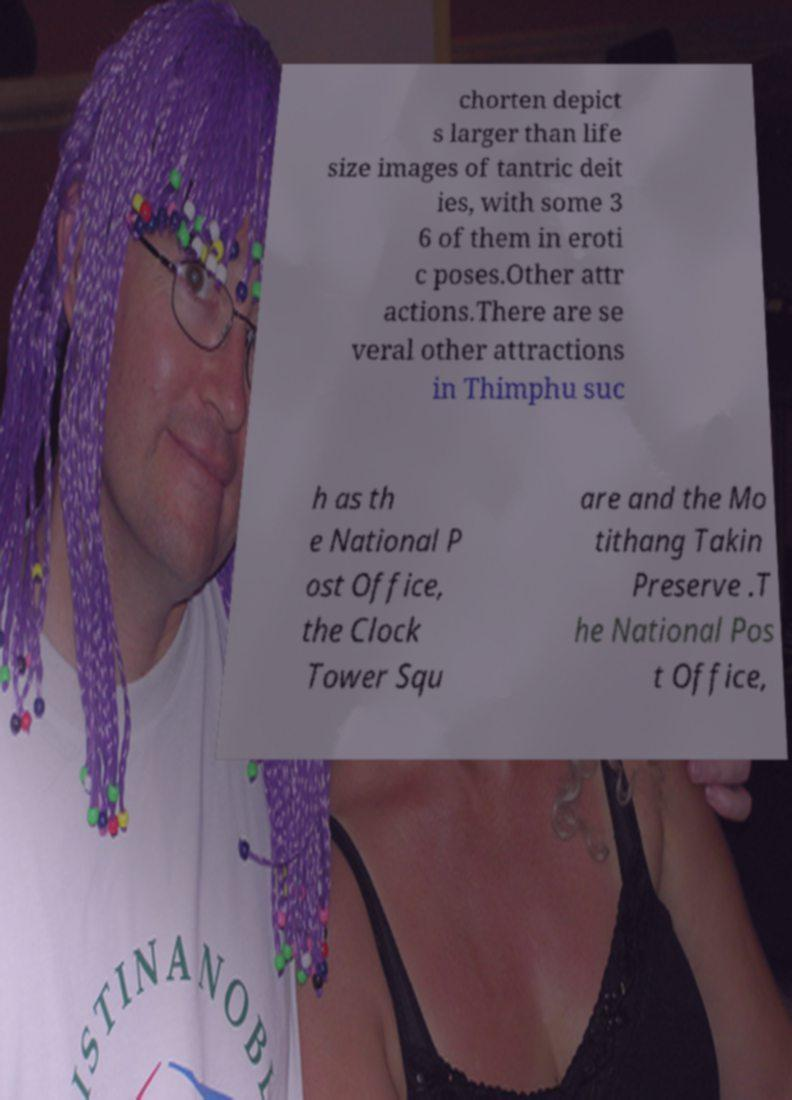Please read and relay the text visible in this image. What does it say? chorten depict s larger than life size images of tantric deit ies, with some 3 6 of them in eroti c poses.Other attr actions.There are se veral other attractions in Thimphu suc h as th e National P ost Office, the Clock Tower Squ are and the Mo tithang Takin Preserve .T he National Pos t Office, 